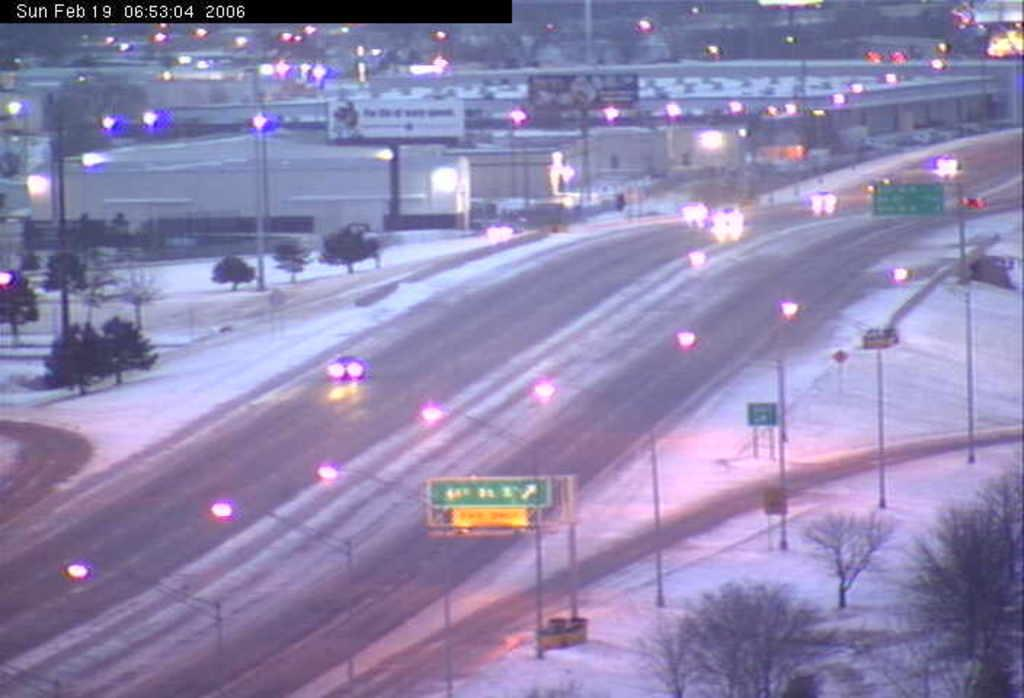What structures are present in the image? There are poles and lights in the image. What type of natural elements can be seen in the image? There are trees in the image. What type of signage is visible in the image? There are name boards in the boards in the image. Where is the vase placed in the image? There is no vase present in the image. What type of ground is visible in the image? The ground is not explicitly visible in the image, but it can be inferred that there is a ground surface supporting the trees and other elements. Can you describe the cannon in the image? There is no cannon present in the image. 